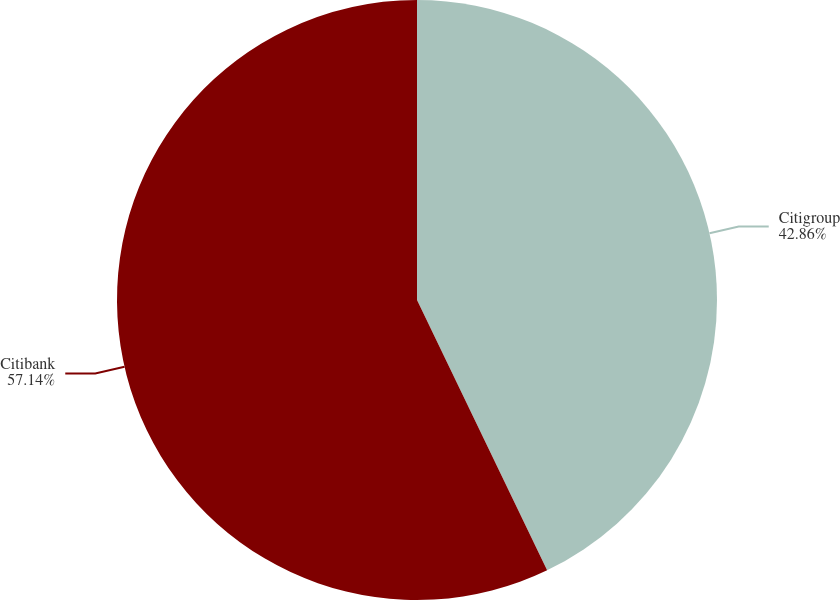<chart> <loc_0><loc_0><loc_500><loc_500><pie_chart><fcel>Citigroup<fcel>Citibank<nl><fcel>42.86%<fcel>57.14%<nl></chart> 